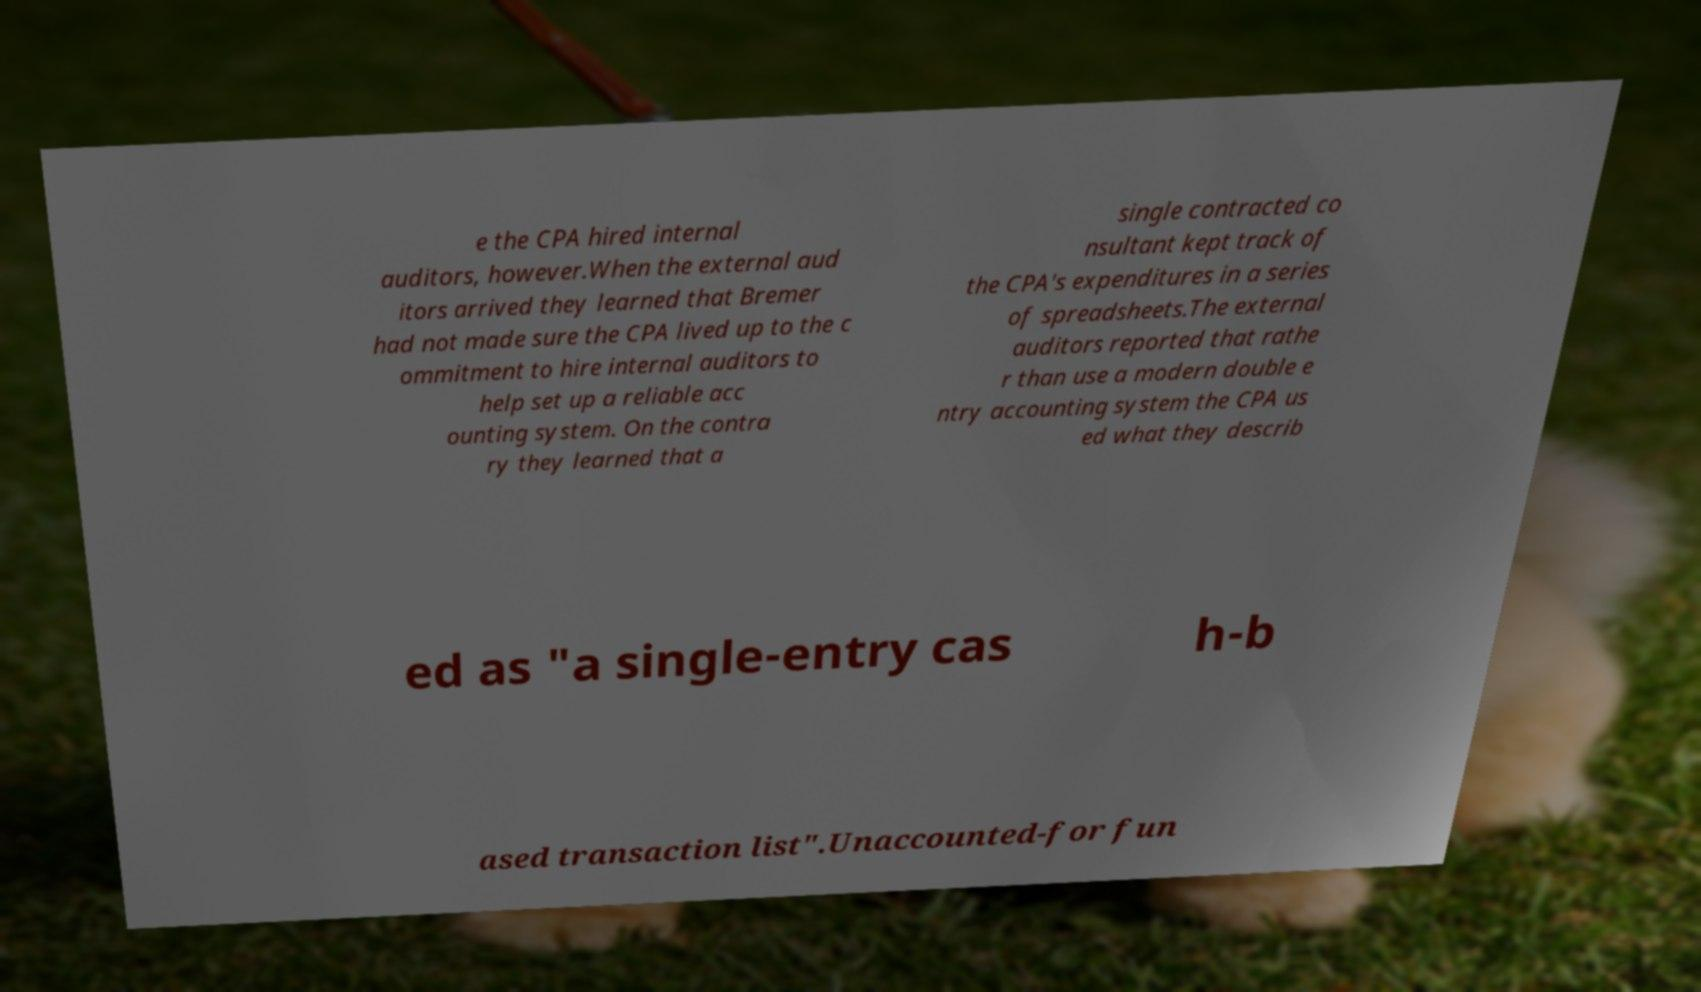What messages or text are displayed in this image? I need them in a readable, typed format. e the CPA hired internal auditors, however.When the external aud itors arrived they learned that Bremer had not made sure the CPA lived up to the c ommitment to hire internal auditors to help set up a reliable acc ounting system. On the contra ry they learned that a single contracted co nsultant kept track of the CPA's expenditures in a series of spreadsheets.The external auditors reported that rathe r than use a modern double e ntry accounting system the CPA us ed what they describ ed as "a single-entry cas h-b ased transaction list".Unaccounted-for fun 